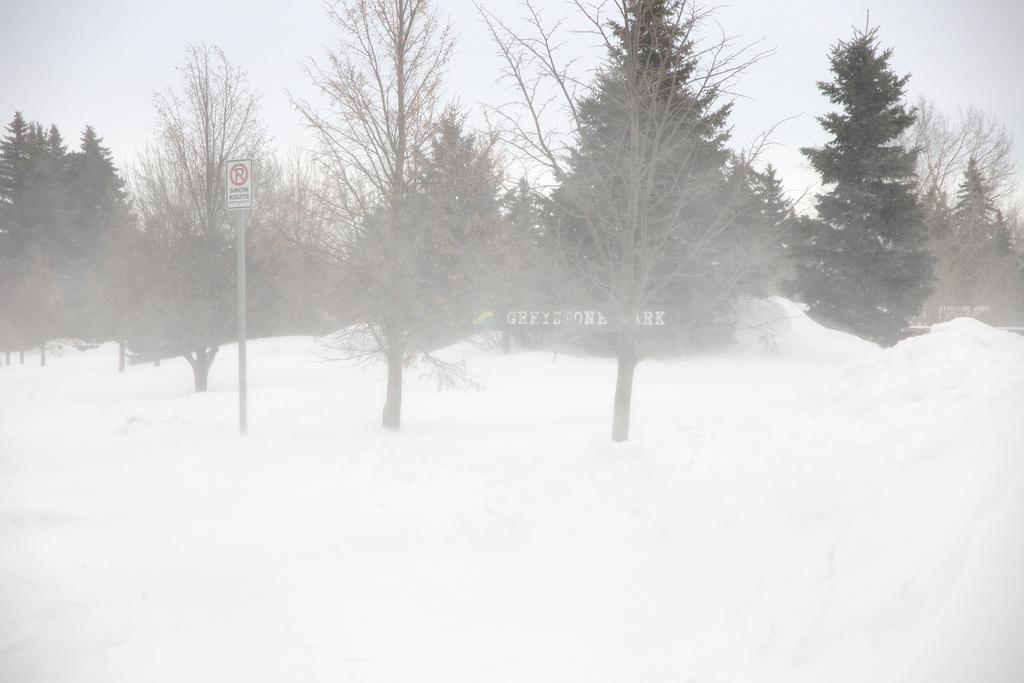What is present in the foreground of the image? There is snow, a pole, and trees in the foreground of the image. What can be seen in the sky in the image? The sky is visible at the top of the image. Can you see a rabbit, an owl, and a pig in the image? There are no rabbits, owls, or pigs present in the image. 